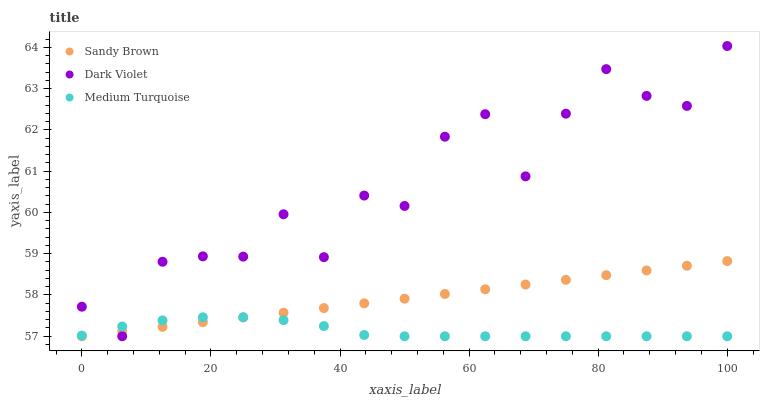Does Medium Turquoise have the minimum area under the curve?
Answer yes or no. Yes. Does Dark Violet have the maximum area under the curve?
Answer yes or no. Yes. Does Dark Violet have the minimum area under the curve?
Answer yes or no. No. Does Medium Turquoise have the maximum area under the curve?
Answer yes or no. No. Is Sandy Brown the smoothest?
Answer yes or no. Yes. Is Dark Violet the roughest?
Answer yes or no. Yes. Is Medium Turquoise the smoothest?
Answer yes or no. No. Is Medium Turquoise the roughest?
Answer yes or no. No. Does Sandy Brown have the lowest value?
Answer yes or no. Yes. Does Dark Violet have the highest value?
Answer yes or no. Yes. Does Medium Turquoise have the highest value?
Answer yes or no. No. Does Medium Turquoise intersect Dark Violet?
Answer yes or no. Yes. Is Medium Turquoise less than Dark Violet?
Answer yes or no. No. Is Medium Turquoise greater than Dark Violet?
Answer yes or no. No. 